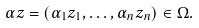Convert formula to latex. <formula><loc_0><loc_0><loc_500><loc_500>\alpha z = ( \alpha _ { 1 } z _ { 1 } , \dots , \alpha _ { n } z _ { n } ) \in \Omega .</formula> 